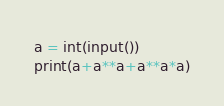<code> <loc_0><loc_0><loc_500><loc_500><_Python_>a = int(input())
print(a+a**a+a**a*a)</code> 